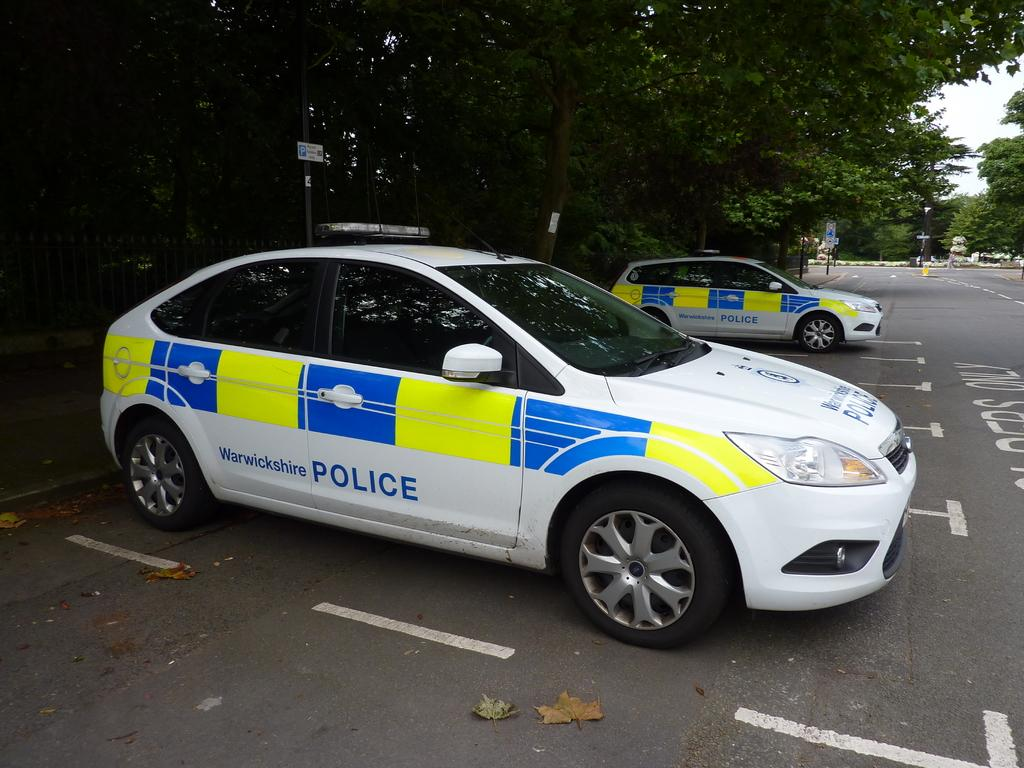How many cars can be seen in the image? There are two cars in the image. What is present on the road in the image? Dried leaves are present on the road. What can be seen in the background of the image? There are trees, boards, and other objects in the background of the image. What is visible in the sky in the image? The sky is visible in the background of the image. What type of sheet is covering the coal in the image? There is no sheet or coal present in the image. How many legs can be seen on the object in the image? There is no object with legs present in the image. 